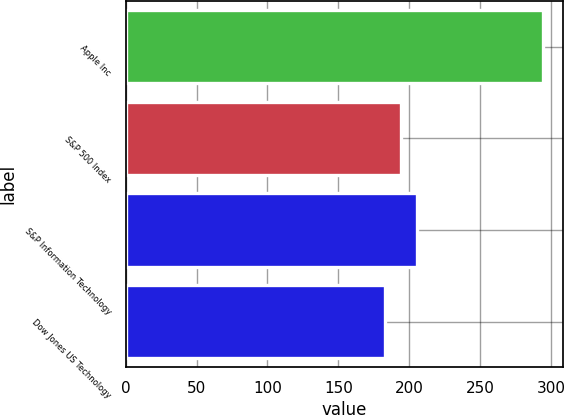Convert chart to OTSL. <chart><loc_0><loc_0><loc_500><loc_500><bar_chart><fcel>Apple Inc<fcel>S&P 500 Index<fcel>S&P Information Technology<fcel>Dow Jones US Technology<nl><fcel>294<fcel>194.1<fcel>205.2<fcel>183<nl></chart> 